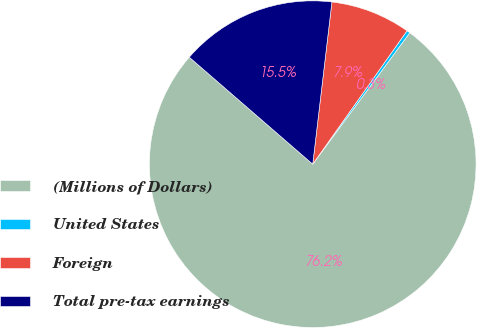Convert chart to OTSL. <chart><loc_0><loc_0><loc_500><loc_500><pie_chart><fcel>(Millions of Dollars)<fcel>United States<fcel>Foreign<fcel>Total pre-tax earnings<nl><fcel>76.24%<fcel>0.33%<fcel>7.92%<fcel>15.51%<nl></chart> 